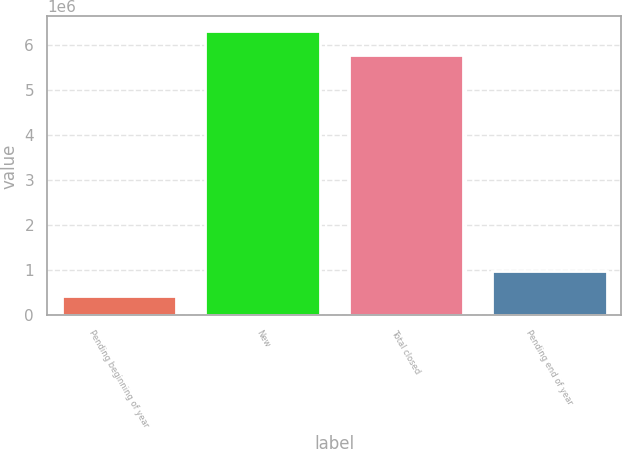Convert chart. <chart><loc_0><loc_0><loc_500><loc_500><bar_chart><fcel>Pending beginning of year<fcel>New<fcel>Total closed<fcel>Pending end of year<nl><fcel>436972<fcel>6.30951e+06<fcel>5.77245e+06<fcel>974030<nl></chart> 